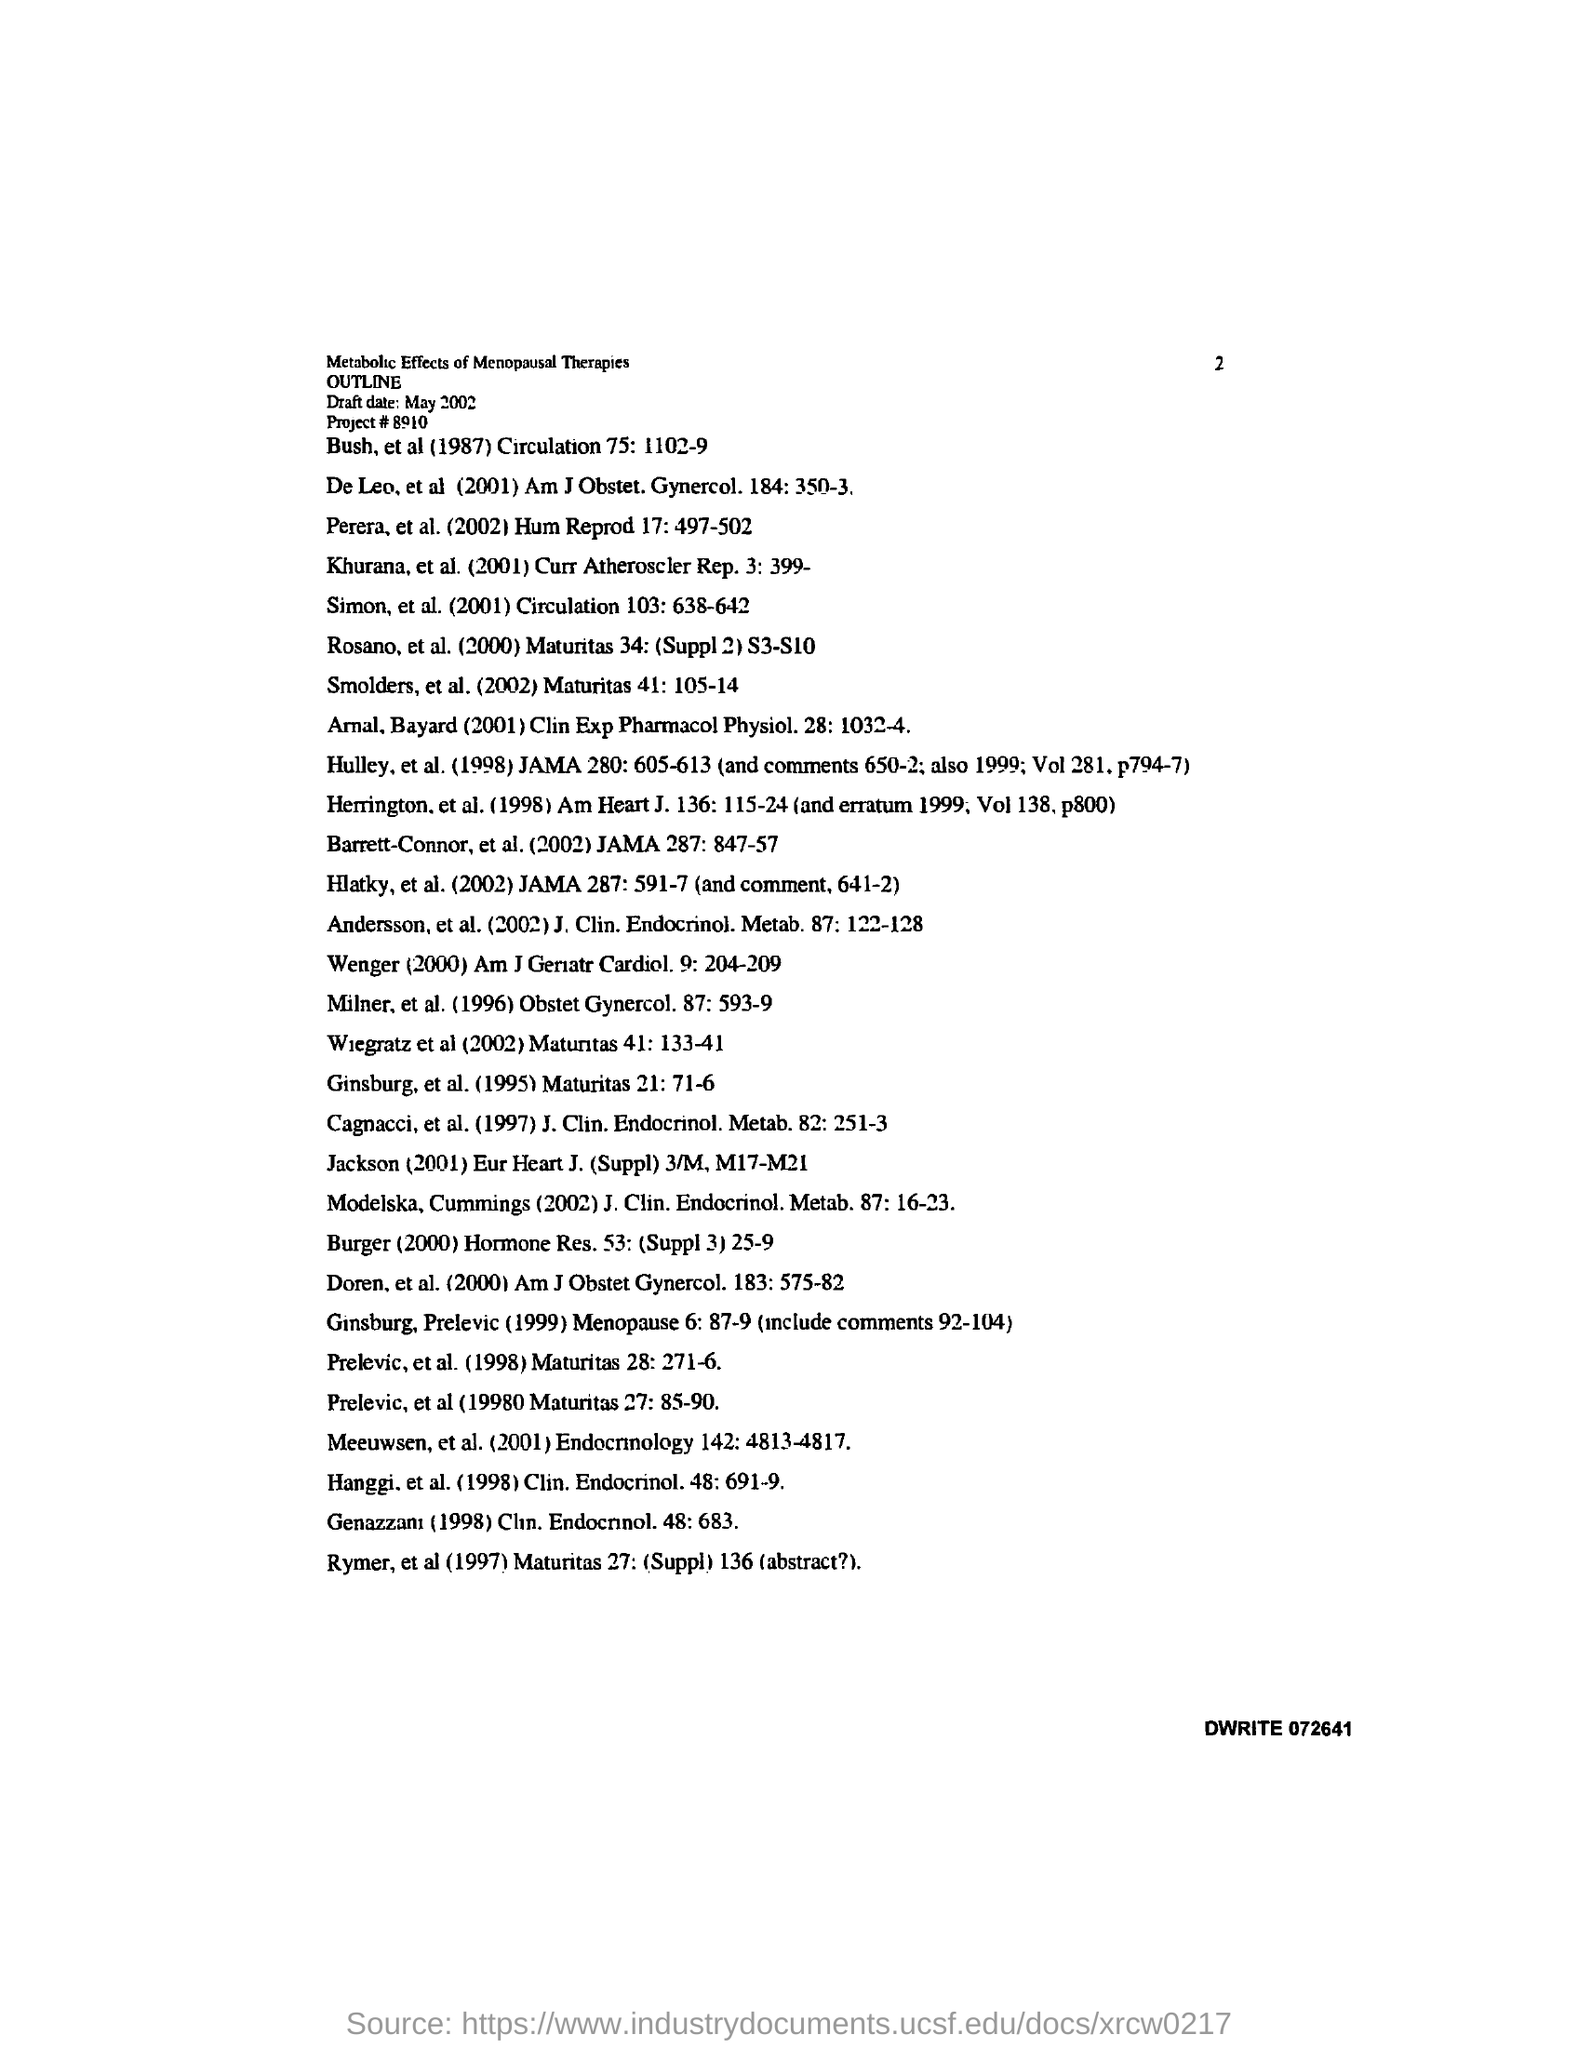What is the Project # number?
Make the answer very short. 8910. What is the date mentioned in the document?
Your response must be concise. May 2002. 